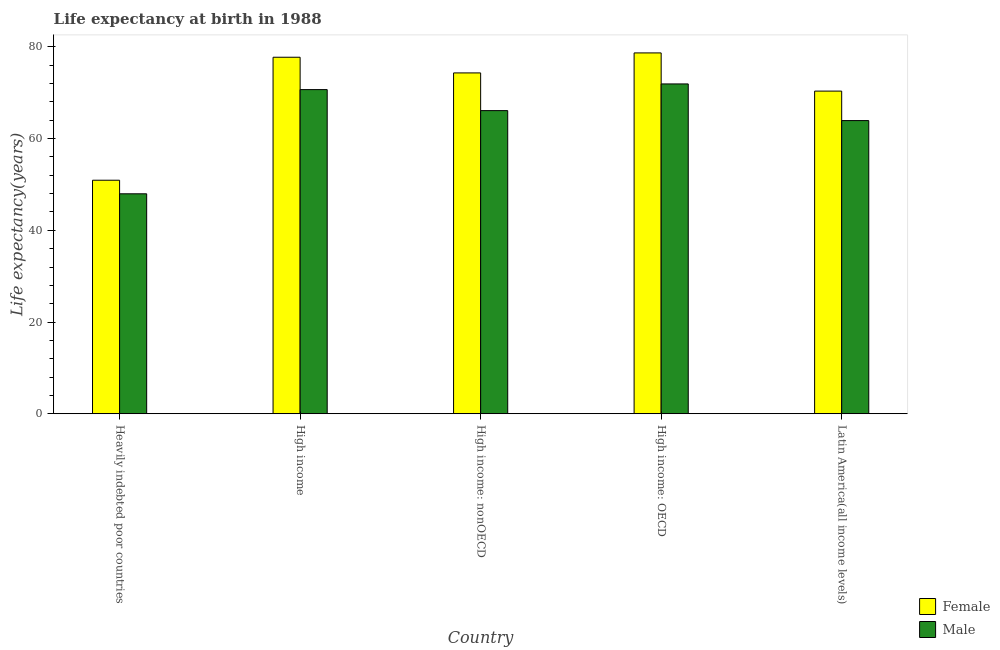How many groups of bars are there?
Your answer should be very brief. 5. Are the number of bars on each tick of the X-axis equal?
Provide a short and direct response. Yes. How many bars are there on the 4th tick from the right?
Make the answer very short. 2. What is the label of the 5th group of bars from the left?
Offer a terse response. Latin America(all income levels). In how many cases, is the number of bars for a given country not equal to the number of legend labels?
Offer a terse response. 0. What is the life expectancy(female) in Latin America(all income levels)?
Your answer should be compact. 70.37. Across all countries, what is the maximum life expectancy(male)?
Give a very brief answer. 71.93. Across all countries, what is the minimum life expectancy(female)?
Provide a succinct answer. 50.93. In which country was the life expectancy(male) maximum?
Your answer should be very brief. High income: OECD. In which country was the life expectancy(female) minimum?
Your response must be concise. Heavily indebted poor countries. What is the total life expectancy(female) in the graph?
Make the answer very short. 352.07. What is the difference between the life expectancy(male) in Heavily indebted poor countries and that in Latin America(all income levels)?
Keep it short and to the point. -15.97. What is the difference between the life expectancy(male) in High income: OECD and the life expectancy(female) in Heavily indebted poor countries?
Give a very brief answer. 21. What is the average life expectancy(female) per country?
Your answer should be compact. 70.41. What is the difference between the life expectancy(female) and life expectancy(male) in High income: OECD?
Your answer should be very brief. 6.77. What is the ratio of the life expectancy(male) in High income: OECD to that in High income: nonOECD?
Provide a succinct answer. 1.09. Is the life expectancy(male) in Heavily indebted poor countries less than that in High income?
Give a very brief answer. Yes. Is the difference between the life expectancy(male) in High income and High income: OECD greater than the difference between the life expectancy(female) in High income and High income: OECD?
Keep it short and to the point. No. What is the difference between the highest and the second highest life expectancy(male)?
Provide a succinct answer. 1.24. What is the difference between the highest and the lowest life expectancy(male)?
Offer a very short reply. 23.96. How many bars are there?
Offer a terse response. 10. Are all the bars in the graph horizontal?
Ensure brevity in your answer.  No. How many countries are there in the graph?
Give a very brief answer. 5. Are the values on the major ticks of Y-axis written in scientific E-notation?
Provide a succinct answer. No. Where does the legend appear in the graph?
Your answer should be very brief. Bottom right. How many legend labels are there?
Provide a succinct answer. 2. What is the title of the graph?
Give a very brief answer. Life expectancy at birth in 1988. What is the label or title of the X-axis?
Provide a succinct answer. Country. What is the label or title of the Y-axis?
Ensure brevity in your answer.  Life expectancy(years). What is the Life expectancy(years) of Female in Heavily indebted poor countries?
Ensure brevity in your answer.  50.93. What is the Life expectancy(years) of Male in Heavily indebted poor countries?
Give a very brief answer. 47.96. What is the Life expectancy(years) of Female in High income?
Offer a terse response. 77.75. What is the Life expectancy(years) of Male in High income?
Your response must be concise. 70.69. What is the Life expectancy(years) of Female in High income: nonOECD?
Give a very brief answer. 74.33. What is the Life expectancy(years) of Male in High income: nonOECD?
Your answer should be compact. 66.11. What is the Life expectancy(years) of Female in High income: OECD?
Offer a terse response. 78.69. What is the Life expectancy(years) in Male in High income: OECD?
Provide a succinct answer. 71.93. What is the Life expectancy(years) in Female in Latin America(all income levels)?
Give a very brief answer. 70.37. What is the Life expectancy(years) in Male in Latin America(all income levels)?
Give a very brief answer. 63.93. Across all countries, what is the maximum Life expectancy(years) in Female?
Offer a terse response. 78.69. Across all countries, what is the maximum Life expectancy(years) in Male?
Your answer should be very brief. 71.93. Across all countries, what is the minimum Life expectancy(years) of Female?
Your answer should be very brief. 50.93. Across all countries, what is the minimum Life expectancy(years) of Male?
Keep it short and to the point. 47.96. What is the total Life expectancy(years) of Female in the graph?
Provide a short and direct response. 352.07. What is the total Life expectancy(years) in Male in the graph?
Provide a short and direct response. 320.62. What is the difference between the Life expectancy(years) in Female in Heavily indebted poor countries and that in High income?
Your answer should be compact. -26.82. What is the difference between the Life expectancy(years) of Male in Heavily indebted poor countries and that in High income?
Offer a terse response. -22.73. What is the difference between the Life expectancy(years) in Female in Heavily indebted poor countries and that in High income: nonOECD?
Your answer should be compact. -23.4. What is the difference between the Life expectancy(years) in Male in Heavily indebted poor countries and that in High income: nonOECD?
Your answer should be compact. -18.14. What is the difference between the Life expectancy(years) of Female in Heavily indebted poor countries and that in High income: OECD?
Ensure brevity in your answer.  -27.77. What is the difference between the Life expectancy(years) in Male in Heavily indebted poor countries and that in High income: OECD?
Ensure brevity in your answer.  -23.96. What is the difference between the Life expectancy(years) in Female in Heavily indebted poor countries and that in Latin America(all income levels)?
Offer a very short reply. -19.44. What is the difference between the Life expectancy(years) in Male in Heavily indebted poor countries and that in Latin America(all income levels)?
Offer a terse response. -15.97. What is the difference between the Life expectancy(years) in Female in High income and that in High income: nonOECD?
Ensure brevity in your answer.  3.42. What is the difference between the Life expectancy(years) of Male in High income and that in High income: nonOECD?
Your answer should be compact. 4.58. What is the difference between the Life expectancy(years) of Female in High income and that in High income: OECD?
Your answer should be very brief. -0.94. What is the difference between the Life expectancy(years) of Male in High income and that in High income: OECD?
Ensure brevity in your answer.  -1.24. What is the difference between the Life expectancy(years) in Female in High income and that in Latin America(all income levels)?
Provide a succinct answer. 7.38. What is the difference between the Life expectancy(years) in Male in High income and that in Latin America(all income levels)?
Your answer should be very brief. 6.76. What is the difference between the Life expectancy(years) in Female in High income: nonOECD and that in High income: OECD?
Offer a terse response. -4.36. What is the difference between the Life expectancy(years) of Male in High income: nonOECD and that in High income: OECD?
Your answer should be very brief. -5.82. What is the difference between the Life expectancy(years) of Female in High income: nonOECD and that in Latin America(all income levels)?
Your answer should be compact. 3.97. What is the difference between the Life expectancy(years) in Male in High income: nonOECD and that in Latin America(all income levels)?
Your answer should be compact. 2.18. What is the difference between the Life expectancy(years) of Female in High income: OECD and that in Latin America(all income levels)?
Your answer should be very brief. 8.33. What is the difference between the Life expectancy(years) of Male in High income: OECD and that in Latin America(all income levels)?
Your answer should be compact. 7.99. What is the difference between the Life expectancy(years) of Female in Heavily indebted poor countries and the Life expectancy(years) of Male in High income?
Your answer should be very brief. -19.76. What is the difference between the Life expectancy(years) of Female in Heavily indebted poor countries and the Life expectancy(years) of Male in High income: nonOECD?
Your answer should be compact. -15.18. What is the difference between the Life expectancy(years) of Female in Heavily indebted poor countries and the Life expectancy(years) of Male in High income: OECD?
Offer a very short reply. -21. What is the difference between the Life expectancy(years) in Female in Heavily indebted poor countries and the Life expectancy(years) in Male in Latin America(all income levels)?
Make the answer very short. -13.01. What is the difference between the Life expectancy(years) of Female in High income and the Life expectancy(years) of Male in High income: nonOECD?
Provide a short and direct response. 11.64. What is the difference between the Life expectancy(years) of Female in High income and the Life expectancy(years) of Male in High income: OECD?
Provide a succinct answer. 5.82. What is the difference between the Life expectancy(years) in Female in High income and the Life expectancy(years) in Male in Latin America(all income levels)?
Your answer should be very brief. 13.82. What is the difference between the Life expectancy(years) in Female in High income: nonOECD and the Life expectancy(years) in Male in High income: OECD?
Keep it short and to the point. 2.4. What is the difference between the Life expectancy(years) of Female in High income: nonOECD and the Life expectancy(years) of Male in Latin America(all income levels)?
Your response must be concise. 10.4. What is the difference between the Life expectancy(years) of Female in High income: OECD and the Life expectancy(years) of Male in Latin America(all income levels)?
Ensure brevity in your answer.  14.76. What is the average Life expectancy(years) of Female per country?
Make the answer very short. 70.41. What is the average Life expectancy(years) of Male per country?
Ensure brevity in your answer.  64.12. What is the difference between the Life expectancy(years) in Female and Life expectancy(years) in Male in Heavily indebted poor countries?
Provide a succinct answer. 2.96. What is the difference between the Life expectancy(years) in Female and Life expectancy(years) in Male in High income?
Offer a very short reply. 7.06. What is the difference between the Life expectancy(years) of Female and Life expectancy(years) of Male in High income: nonOECD?
Ensure brevity in your answer.  8.22. What is the difference between the Life expectancy(years) in Female and Life expectancy(years) in Male in High income: OECD?
Provide a short and direct response. 6.77. What is the difference between the Life expectancy(years) in Female and Life expectancy(years) in Male in Latin America(all income levels)?
Keep it short and to the point. 6.43. What is the ratio of the Life expectancy(years) of Female in Heavily indebted poor countries to that in High income?
Your answer should be very brief. 0.66. What is the ratio of the Life expectancy(years) in Male in Heavily indebted poor countries to that in High income?
Offer a very short reply. 0.68. What is the ratio of the Life expectancy(years) in Female in Heavily indebted poor countries to that in High income: nonOECD?
Your answer should be very brief. 0.69. What is the ratio of the Life expectancy(years) in Male in Heavily indebted poor countries to that in High income: nonOECD?
Offer a terse response. 0.73. What is the ratio of the Life expectancy(years) in Female in Heavily indebted poor countries to that in High income: OECD?
Provide a short and direct response. 0.65. What is the ratio of the Life expectancy(years) in Male in Heavily indebted poor countries to that in High income: OECD?
Your response must be concise. 0.67. What is the ratio of the Life expectancy(years) of Female in Heavily indebted poor countries to that in Latin America(all income levels)?
Provide a short and direct response. 0.72. What is the ratio of the Life expectancy(years) in Male in Heavily indebted poor countries to that in Latin America(all income levels)?
Your answer should be compact. 0.75. What is the ratio of the Life expectancy(years) in Female in High income to that in High income: nonOECD?
Provide a short and direct response. 1.05. What is the ratio of the Life expectancy(years) of Male in High income to that in High income: nonOECD?
Offer a very short reply. 1.07. What is the ratio of the Life expectancy(years) of Male in High income to that in High income: OECD?
Provide a short and direct response. 0.98. What is the ratio of the Life expectancy(years) in Female in High income to that in Latin America(all income levels)?
Provide a short and direct response. 1.1. What is the ratio of the Life expectancy(years) in Male in High income to that in Latin America(all income levels)?
Offer a terse response. 1.11. What is the ratio of the Life expectancy(years) in Female in High income: nonOECD to that in High income: OECD?
Provide a succinct answer. 0.94. What is the ratio of the Life expectancy(years) of Male in High income: nonOECD to that in High income: OECD?
Make the answer very short. 0.92. What is the ratio of the Life expectancy(years) in Female in High income: nonOECD to that in Latin America(all income levels)?
Offer a very short reply. 1.06. What is the ratio of the Life expectancy(years) of Male in High income: nonOECD to that in Latin America(all income levels)?
Give a very brief answer. 1.03. What is the ratio of the Life expectancy(years) in Female in High income: OECD to that in Latin America(all income levels)?
Your response must be concise. 1.12. What is the ratio of the Life expectancy(years) in Male in High income: OECD to that in Latin America(all income levels)?
Make the answer very short. 1.12. What is the difference between the highest and the second highest Life expectancy(years) in Female?
Your answer should be very brief. 0.94. What is the difference between the highest and the second highest Life expectancy(years) in Male?
Offer a very short reply. 1.24. What is the difference between the highest and the lowest Life expectancy(years) in Female?
Provide a short and direct response. 27.77. What is the difference between the highest and the lowest Life expectancy(years) of Male?
Offer a terse response. 23.96. 